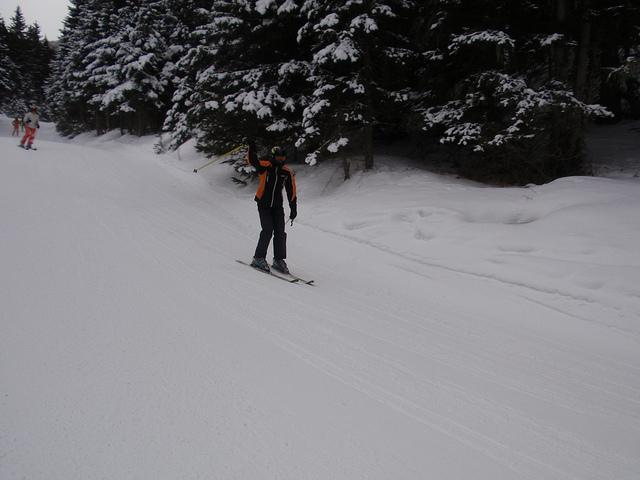Why is the man raising his arm while skiing? Please explain your reasoning. claiming victory. The man appears to be ahead of the others and appears to be holding his hand up in victory. when people win races, they sometimes hold their hands up to celebrate. 